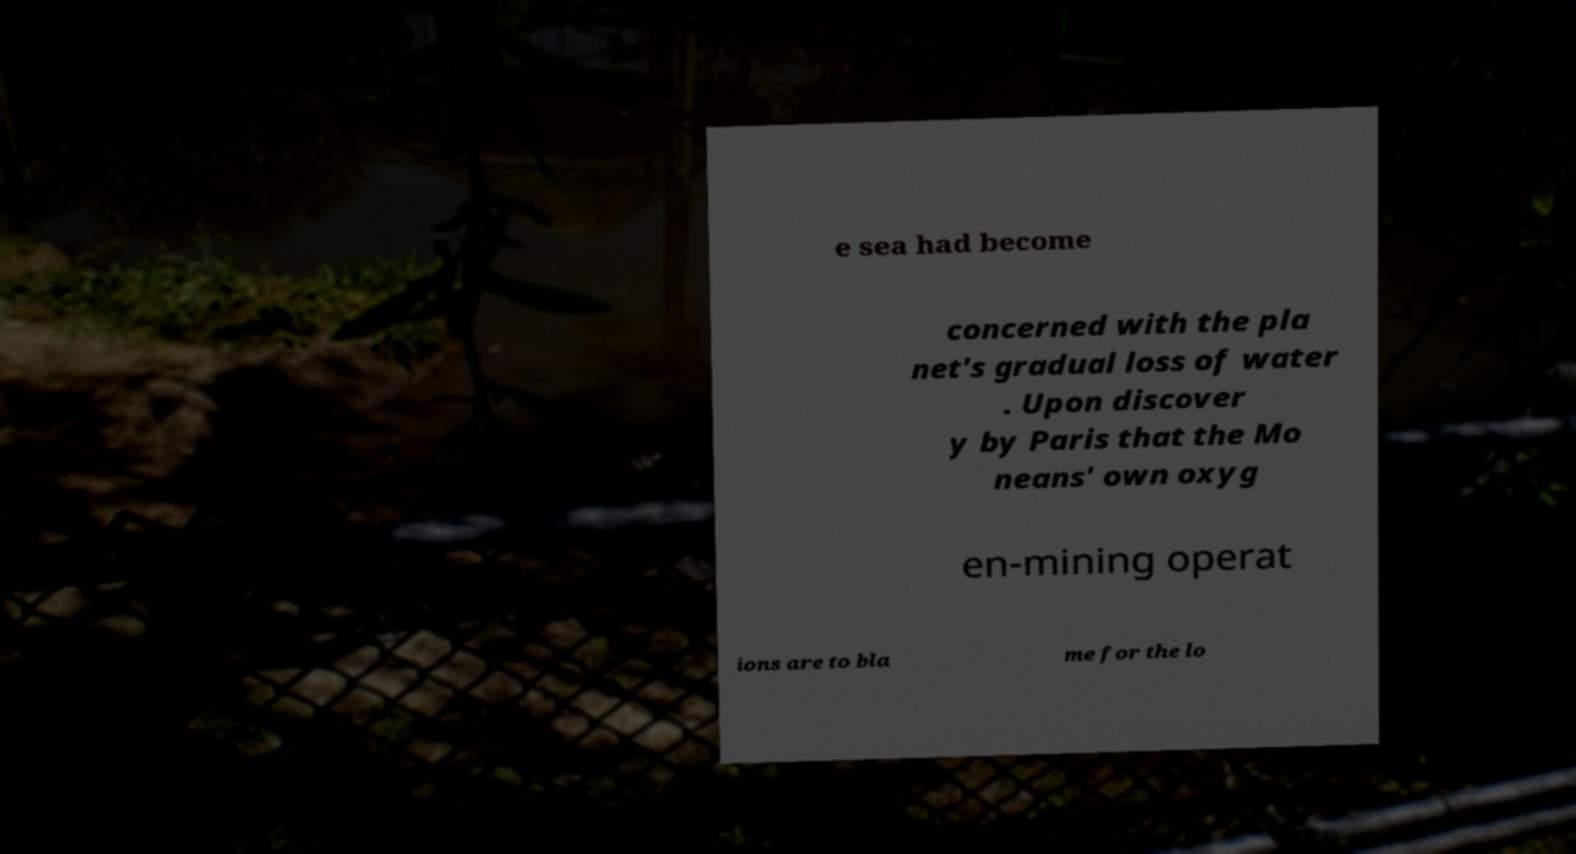Could you assist in decoding the text presented in this image and type it out clearly? e sea had become concerned with the pla net's gradual loss of water . Upon discover y by Paris that the Mo neans' own oxyg en-mining operat ions are to bla me for the lo 